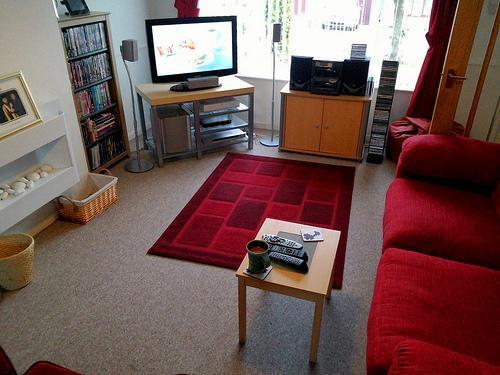How many rugs are there?
Give a very brief answer. 1. How many black remotes are on the table?
Give a very brief answer. 2. 